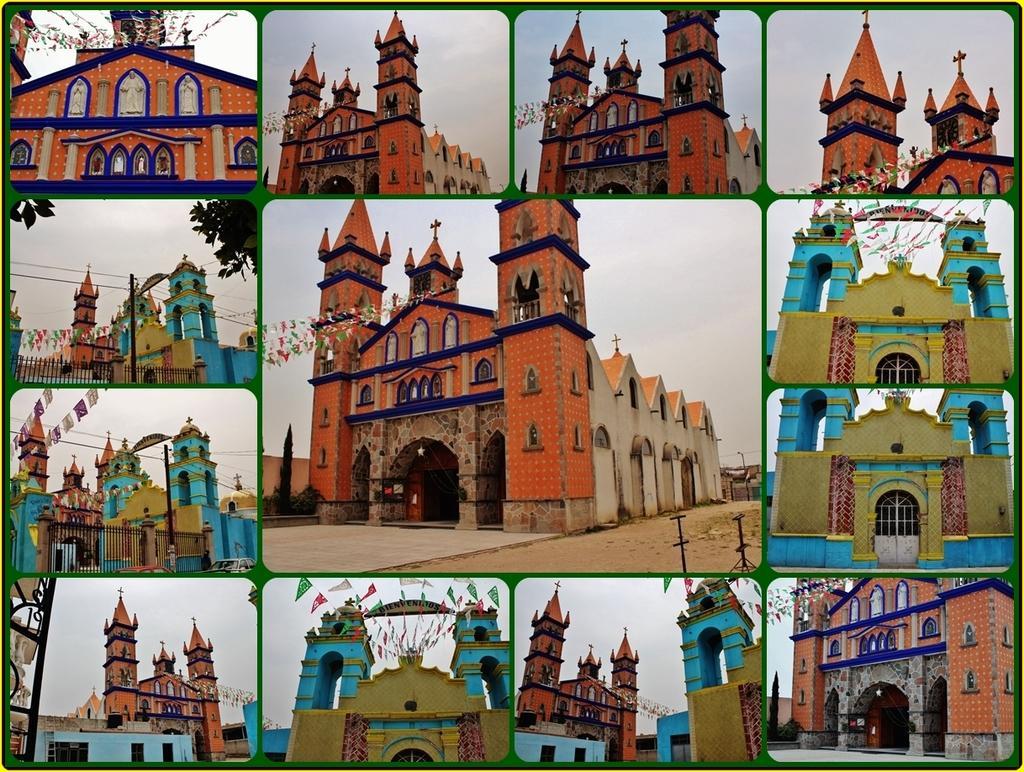Please provide a concise description of this image. This is collage image, in each image there is a church. 